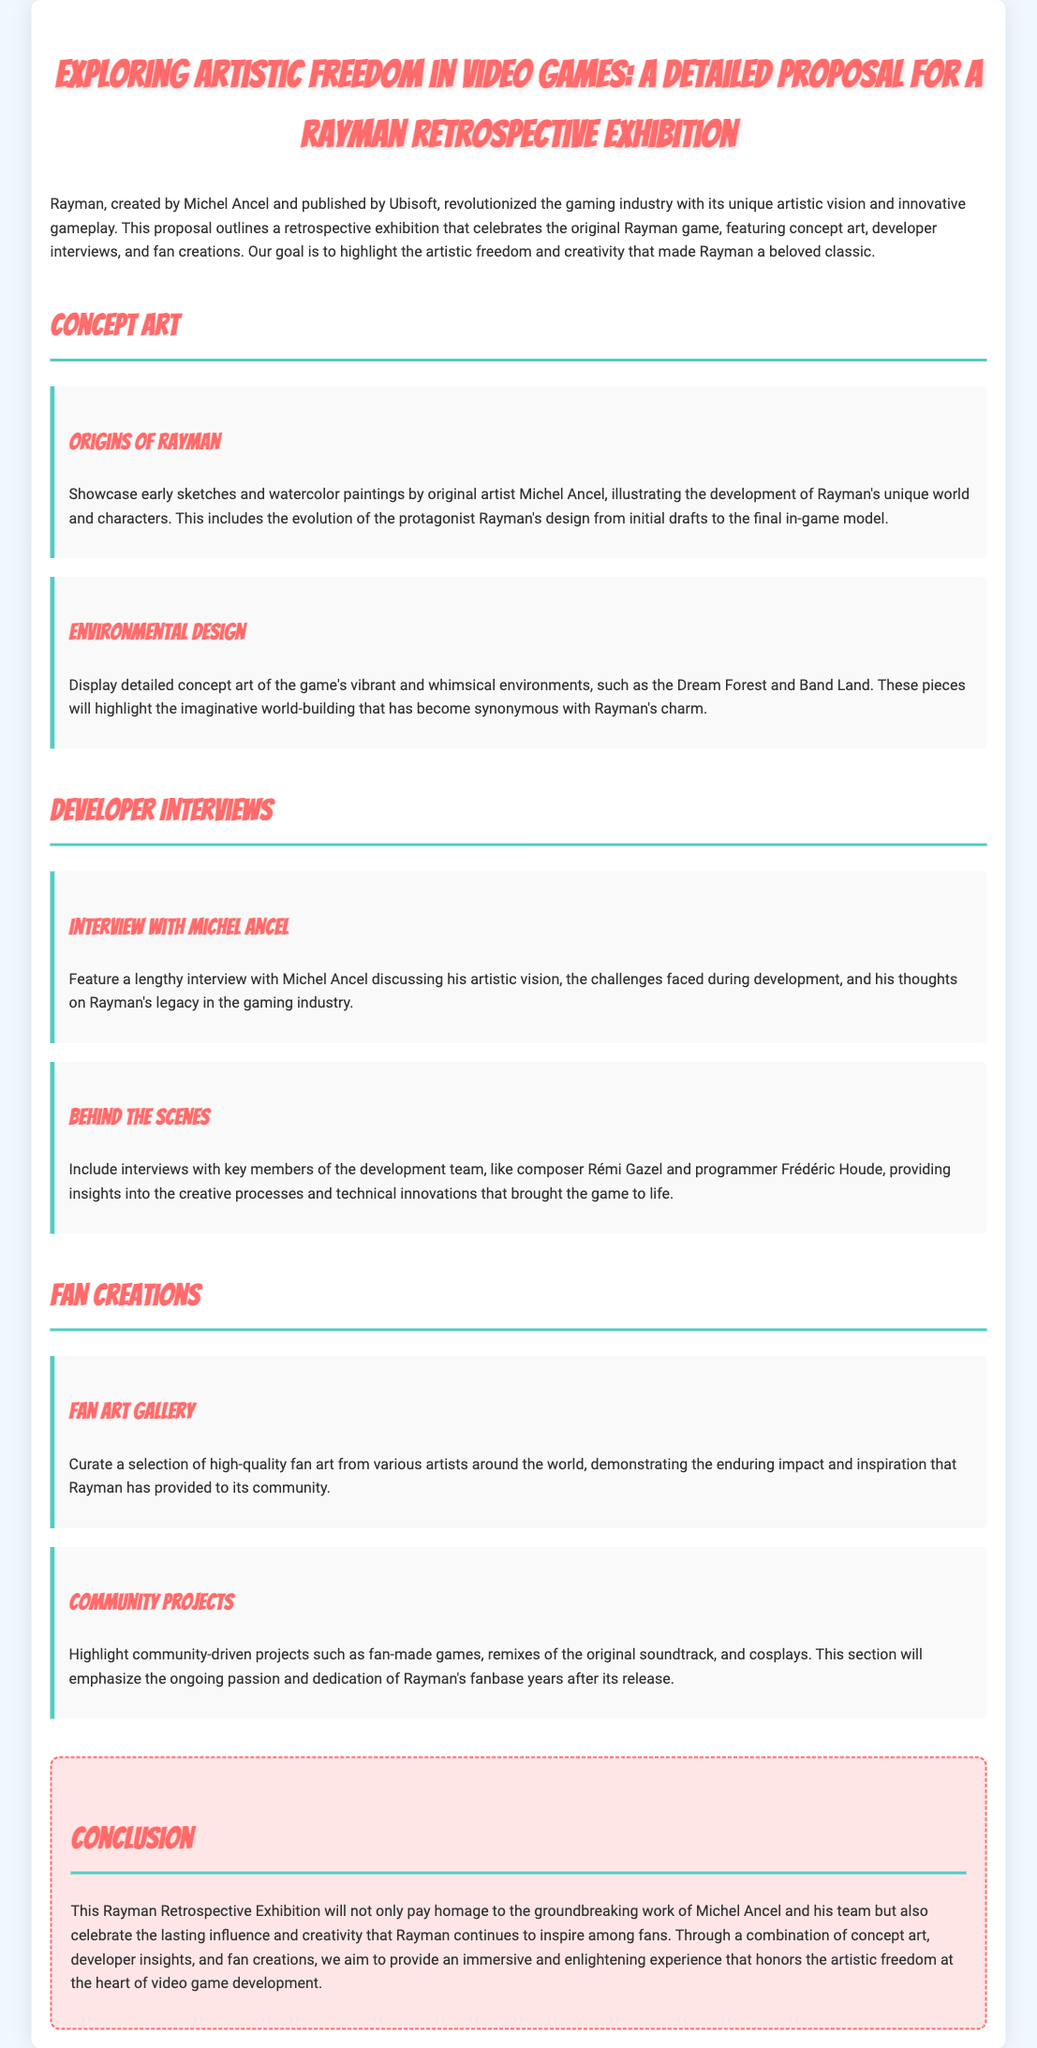What is the title of the exhibition? The title of the exhibition is explicitly stated at the top of the document, "Exploring Artistic Freedom in Video Games: A Detailed Proposal for a Rayman Retrospective Exhibition."
Answer: Exploring Artistic Freedom in Video Games: A Detailed Proposal for a Rayman Retrospective Exhibition Who created Rayman? The document mentions that Rayman was created by Michel Ancel in the opening paragraph.
Answer: Michel Ancel What artistic feature is highlighted in the proposal? The proposal emphasizes the theme of "artistic freedom" throughout, particularly in relation to the game's design and development.
Answer: Artistic freedom Which character’s design evolution is showcased? It specifies that the evolution of protagonist Rayman's design is a focus in the concept art section.
Answer: Rayman What type of content is featured in the Fan Art Gallery? The document states that the Fan Art Gallery will showcase high-quality fan art from various artists.
Answer: High-quality fan art How many sections are in the Developer Interviews part? There are two sections mentioned, one featuring Michel Ancel and another with key development team members.
Answer: Two What is the conclusion's main focus? The conclusion emphasizes the lasting influence and creativity that Rayman inspires among fans and the importance of the retrospective exhibition.
Answer: Lasting influence and creativity What type of projects are highlighted in the community section? The document refers to community-driven projects such as fan-made games and remixes of the original soundtrack.
Answer: Community-driven projects Who discusses their artistic vision in the exhibition? Michel Ancel discusses his artistic vision in a dedicated interview included in the exhibition.
Answer: Michel Ancel 